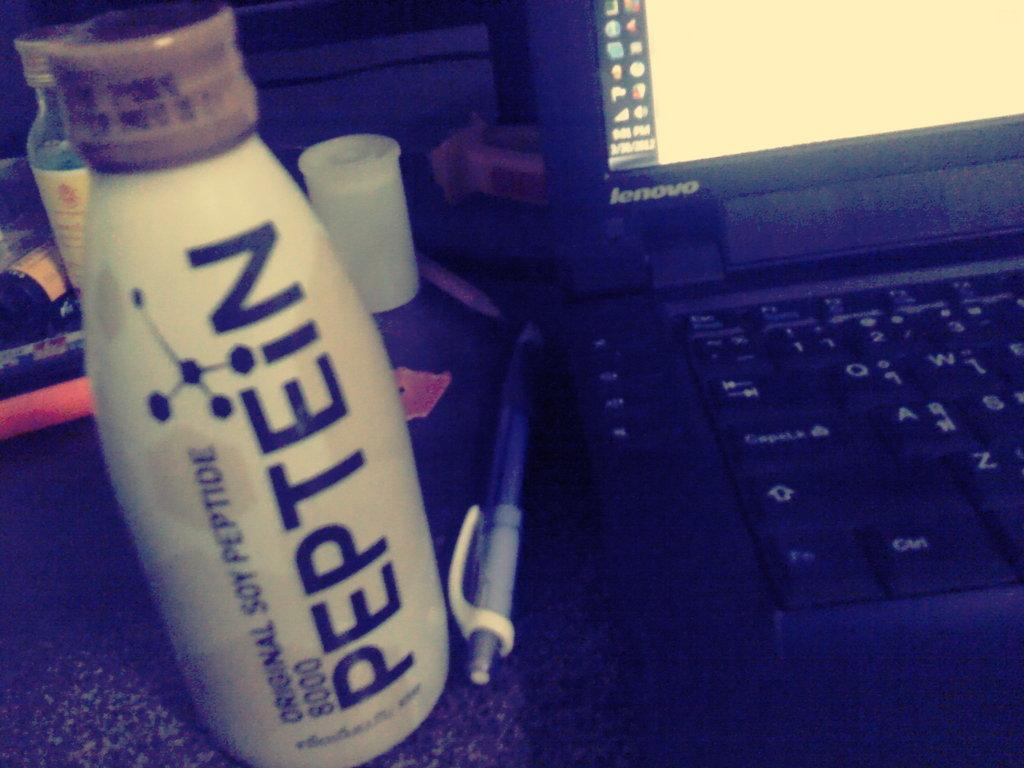<image>
Provide a brief description of the given image. Bottle named Peptein next to a Lenovo laptop. 